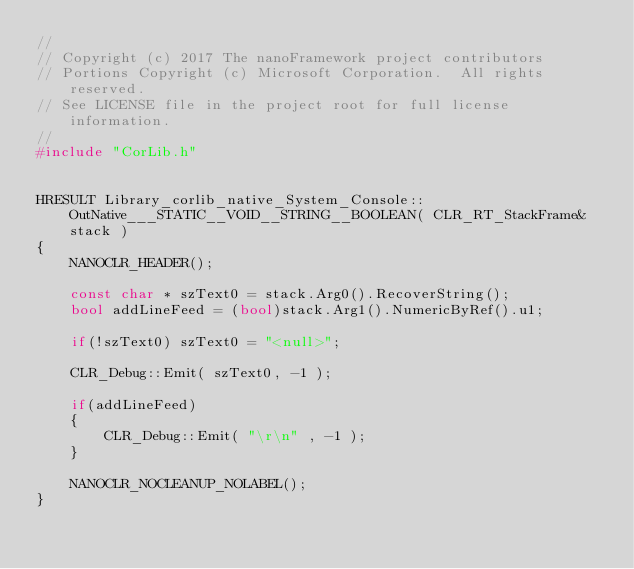Convert code to text. <code><loc_0><loc_0><loc_500><loc_500><_C++_>//
// Copyright (c) 2017 The nanoFramework project contributors
// Portions Copyright (c) Microsoft Corporation.  All rights reserved.
// See LICENSE file in the project root for full license information.
//
#include "CorLib.h"


HRESULT Library_corlib_native_System_Console::OutNative___STATIC__VOID__STRING__BOOLEAN( CLR_RT_StackFrame& stack )
{
    NANOCLR_HEADER();

    const char * szText0 = stack.Arg0().RecoverString();
    bool addLineFeed = (bool)stack.Arg1().NumericByRef().u1;

    if(!szText0) szText0 = "<null>";

    CLR_Debug::Emit( szText0, -1 );

    if(addLineFeed)
    {
        CLR_Debug::Emit( "\r\n" , -1 );
    }

    NANOCLR_NOCLEANUP_NOLABEL();    
}
</code> 